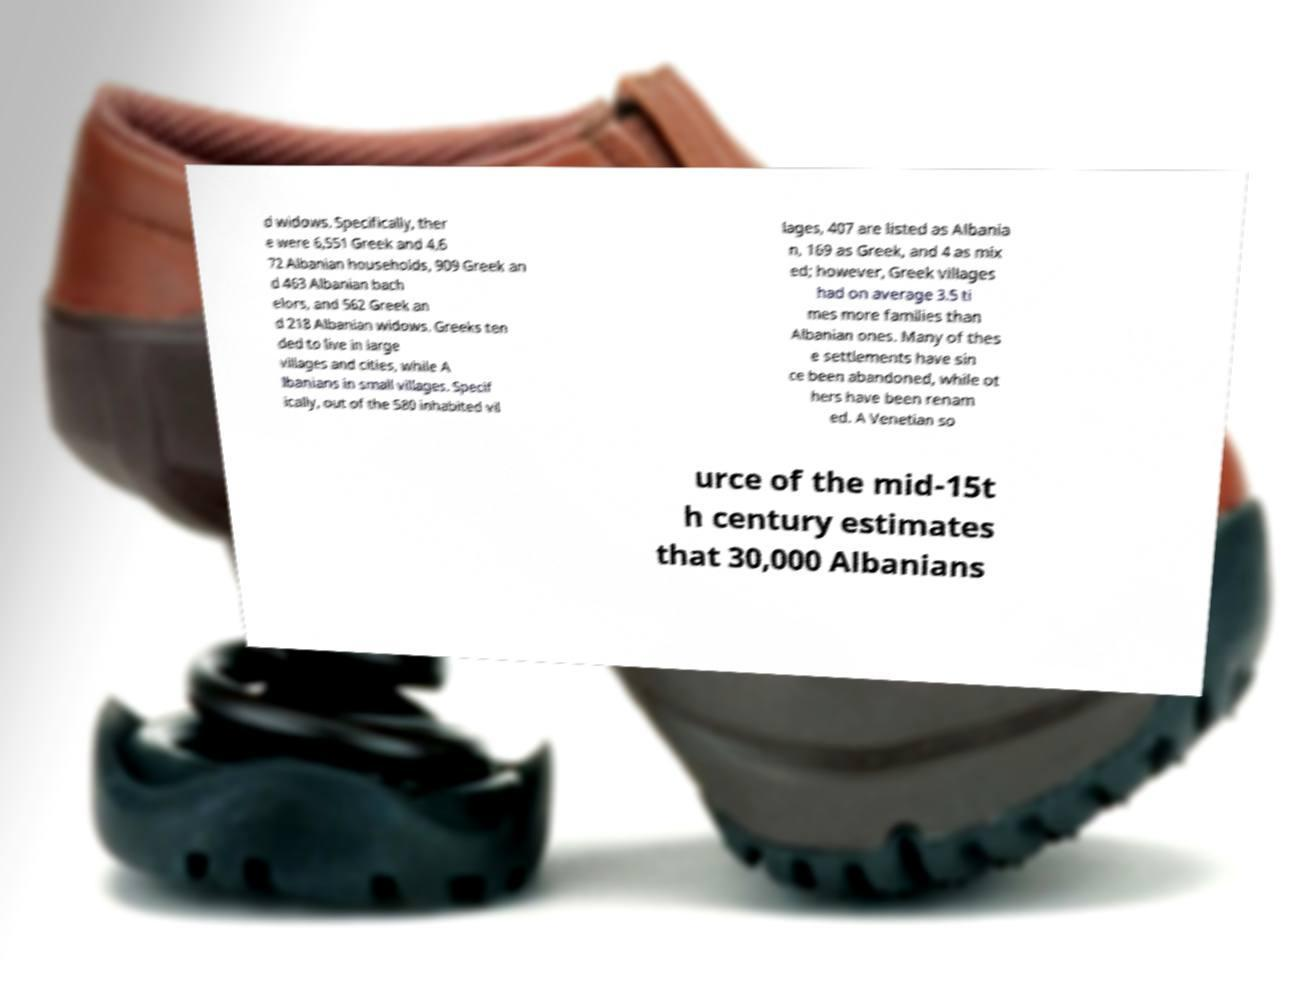What messages or text are displayed in this image? I need them in a readable, typed format. d widows. Specifically, ther e were 6,551 Greek and 4,6 72 Albanian households, 909 Greek an d 463 Albanian bach elors, and 562 Greek an d 218 Albanian widows. Greeks ten ded to live in large villages and cities, while A lbanians in small villages. Specif ically, out of the 580 inhabited vil lages, 407 are listed as Albania n, 169 as Greek, and 4 as mix ed; however, Greek villages had on average 3.5 ti mes more families than Albanian ones. Many of thes e settlements have sin ce been abandoned, while ot hers have been renam ed. A Venetian so urce of the mid-15t h century estimates that 30,000 Albanians 